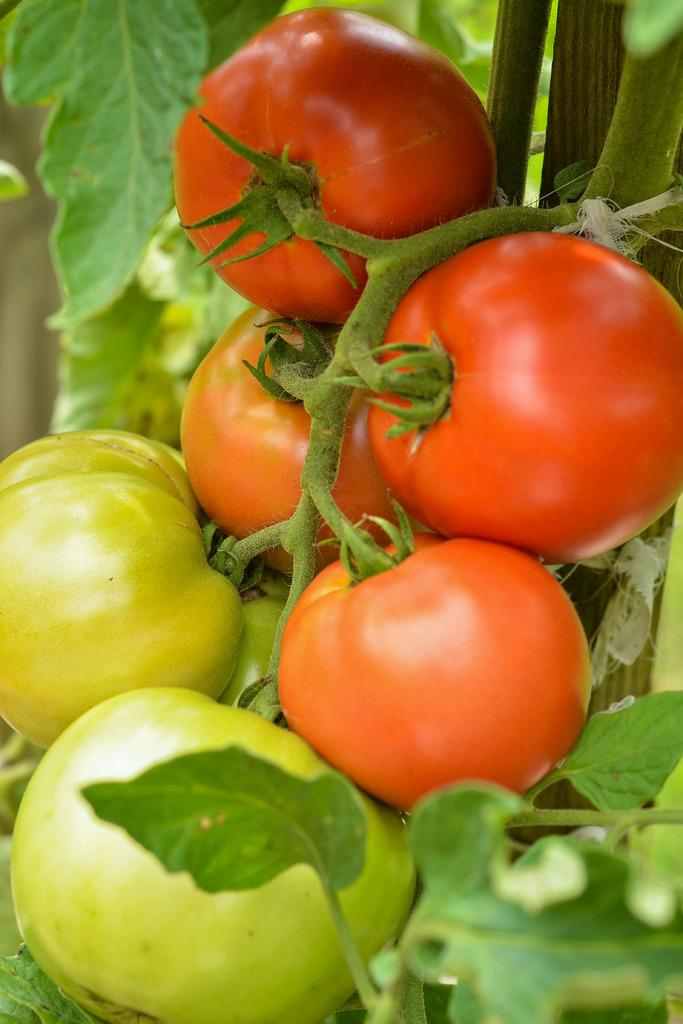What type of fruit can be seen in the image? There are tomatoes in the image. What else is present in the image besides the tomatoes? There are leaves in the image. Can you tell me how many noses are visible in the image? There are no noses present in the image; it features tomatoes and leaves. What type of prose can be heard in the background of the image? There is no audio or prose present in the image, as it is a still image of tomatoes and leaves. 